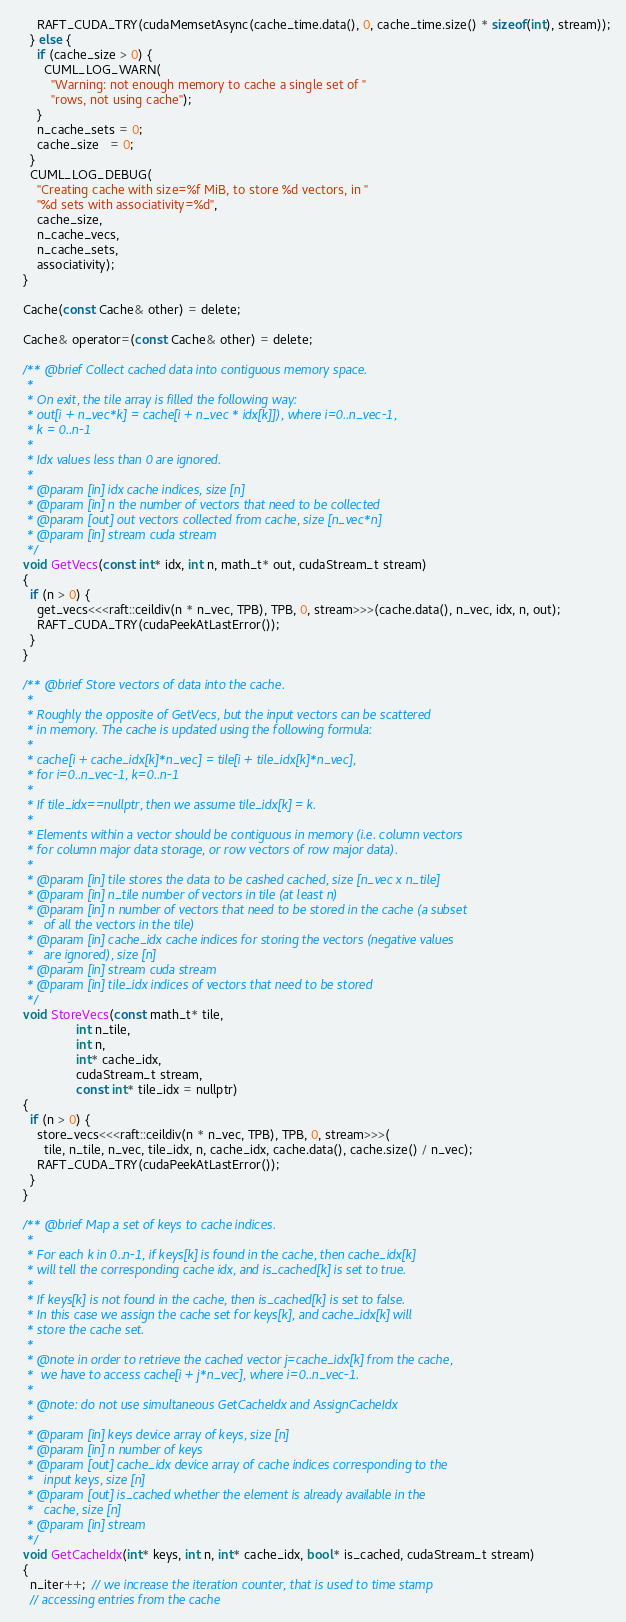Convert code to text. <code><loc_0><loc_0><loc_500><loc_500><_Cuda_>      RAFT_CUDA_TRY(cudaMemsetAsync(cache_time.data(), 0, cache_time.size() * sizeof(int), stream));
    } else {
      if (cache_size > 0) {
        CUML_LOG_WARN(
          "Warning: not enough memory to cache a single set of "
          "rows, not using cache");
      }
      n_cache_sets = 0;
      cache_size   = 0;
    }
    CUML_LOG_DEBUG(
      "Creating cache with size=%f MiB, to store %d vectors, in "
      "%d sets with associativity=%d",
      cache_size,
      n_cache_vecs,
      n_cache_sets,
      associativity);
  }

  Cache(const Cache& other) = delete;

  Cache& operator=(const Cache& other) = delete;

  /** @brief Collect cached data into contiguous memory space.
   *
   * On exit, the tile array is filled the following way:
   * out[i + n_vec*k] = cache[i + n_vec * idx[k]]), where i=0..n_vec-1,
   * k = 0..n-1
   *
   * Idx values less than 0 are ignored.
   *
   * @param [in] idx cache indices, size [n]
   * @param [in] n the number of vectors that need to be collected
   * @param [out] out vectors collected from cache, size [n_vec*n]
   * @param [in] stream cuda stream
   */
  void GetVecs(const int* idx, int n, math_t* out, cudaStream_t stream)
  {
    if (n > 0) {
      get_vecs<<<raft::ceildiv(n * n_vec, TPB), TPB, 0, stream>>>(cache.data(), n_vec, idx, n, out);
      RAFT_CUDA_TRY(cudaPeekAtLastError());
    }
  }

  /** @brief Store vectors of data into the cache.
   *
   * Roughly the opposite of GetVecs, but the input vectors can be scattered
   * in memory. The cache is updated using the following formula:
   *
   * cache[i + cache_idx[k]*n_vec] = tile[i + tile_idx[k]*n_vec],
   * for i=0..n_vec-1, k=0..n-1
   *
   * If tile_idx==nullptr, then we assume tile_idx[k] = k.
   *
   * Elements within a vector should be contiguous in memory (i.e. column vectors
   * for column major data storage, or row vectors of row major data).
   *
   * @param [in] tile stores the data to be cashed cached, size [n_vec x n_tile]
   * @param [in] n_tile number of vectors in tile (at least n)
   * @param [in] n number of vectors that need to be stored in the cache (a subset
   *   of all the vectors in the tile)
   * @param [in] cache_idx cache indices for storing the vectors (negative values
   *   are ignored), size [n]
   * @param [in] stream cuda stream
   * @param [in] tile_idx indices of vectors that need to be stored
   */
  void StoreVecs(const math_t* tile,
                 int n_tile,
                 int n,
                 int* cache_idx,
                 cudaStream_t stream,
                 const int* tile_idx = nullptr)
  {
    if (n > 0) {
      store_vecs<<<raft::ceildiv(n * n_vec, TPB), TPB, 0, stream>>>(
        tile, n_tile, n_vec, tile_idx, n, cache_idx, cache.data(), cache.size() / n_vec);
      RAFT_CUDA_TRY(cudaPeekAtLastError());
    }
  }

  /** @brief Map a set of keys to cache indices.
   *
   * For each k in 0..n-1, if keys[k] is found in the cache, then cache_idx[k]
   * will tell the corresponding cache idx, and is_cached[k] is set to true.
   *
   * If keys[k] is not found in the cache, then is_cached[k] is set to false.
   * In this case we assign the cache set for keys[k], and cache_idx[k] will
   * store the cache set.
   *
   * @note in order to retrieve the cached vector j=cache_idx[k] from the cache,
   *  we have to access cache[i + j*n_vec], where i=0..n_vec-1.
   *
   * @note: do not use simultaneous GetCacheIdx and AssignCacheIdx
   *
   * @param [in] keys device array of keys, size [n]
   * @param [in] n number of keys
   * @param [out] cache_idx device array of cache indices corresponding to the
   *   input keys, size [n]
   * @param [out] is_cached whether the element is already available in the
   *   cache, size [n]
   * @param [in] stream
   */
  void GetCacheIdx(int* keys, int n, int* cache_idx, bool* is_cached, cudaStream_t stream)
  {
    n_iter++;  // we increase the iteration counter, that is used to time stamp
    // accessing entries from the cache</code> 